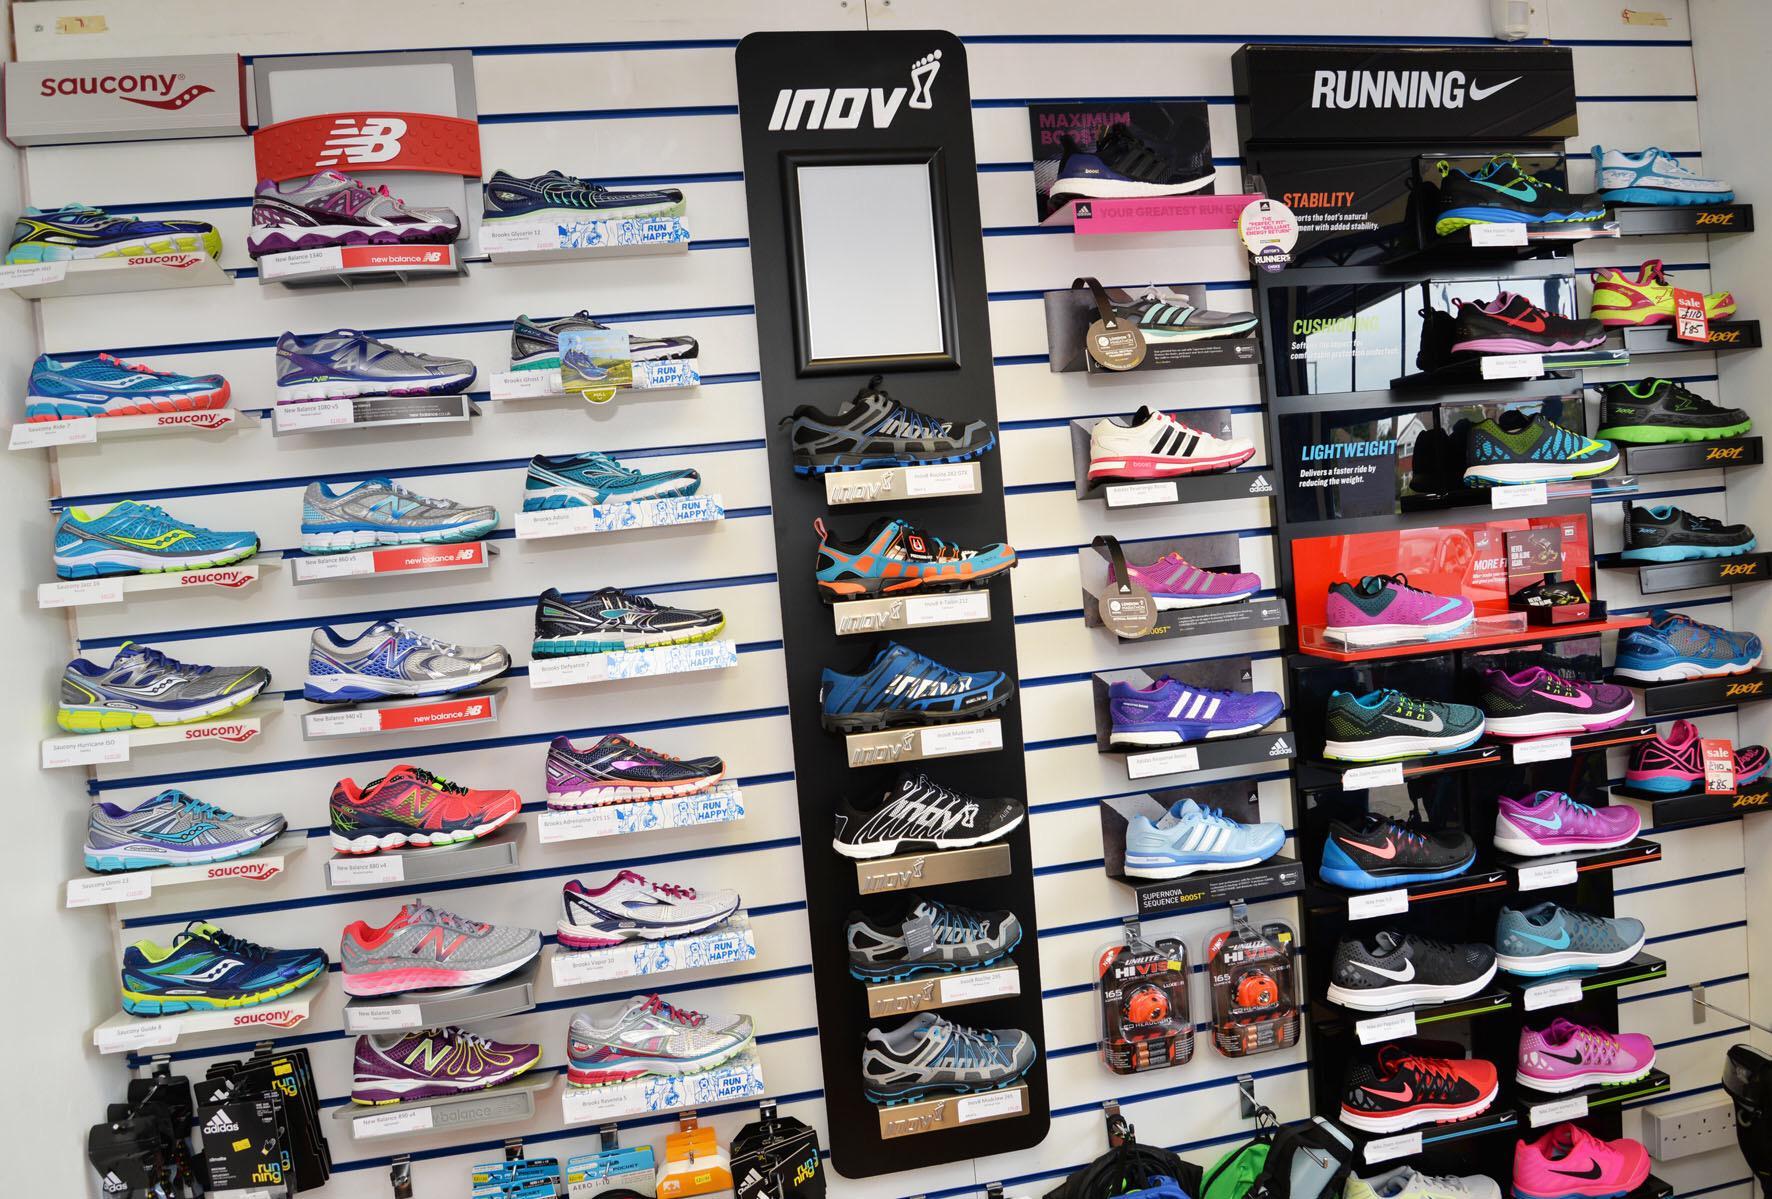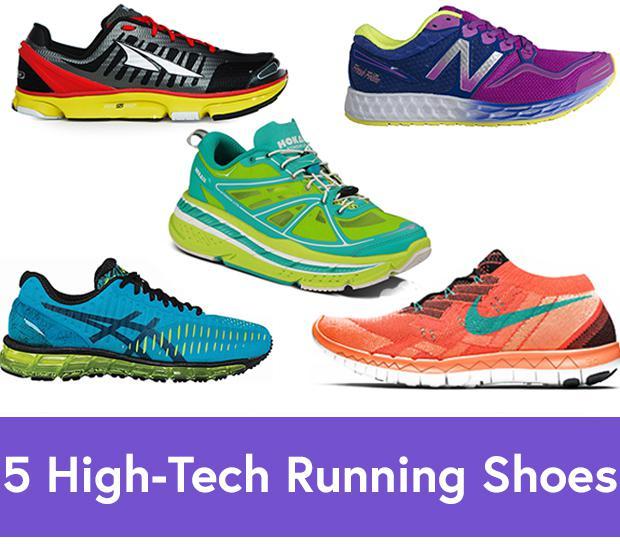The first image is the image on the left, the second image is the image on the right. Analyze the images presented: Is the assertion "One image has less than sixteen shoes present." valid? Answer yes or no. Yes. 